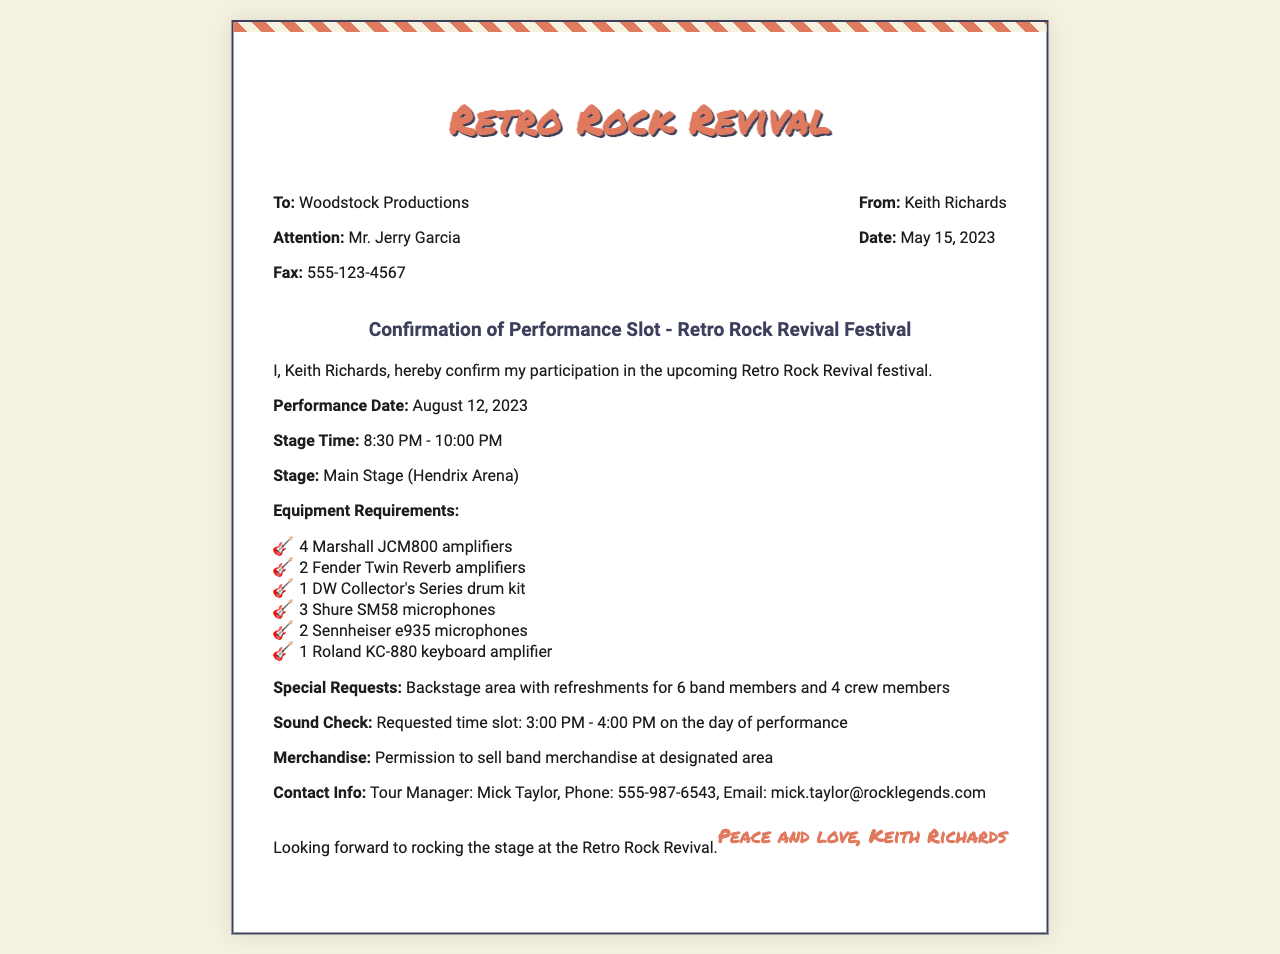What is the performance date? The performance date is explicitly mentioned in the document as August 12, 2023.
Answer: August 12, 2023 What time does the performance start? The start time of the performance is listed as 8:30 PM in the document.
Answer: 8:30 PM How many crew members are specified in special requests? The document states there will be 4 crew members alongside 6 band members in the special requests.
Answer: 4 What is the name of the stage where the performance will take place? The document specifically mentions that the performance will occur at the Main Stage (Hendrix Arena).
Answer: Main Stage (Hendrix Arena) What is the requested time slot for the sound check? The document provides the requested time for the sound check as 3:00 PM to 4:00 PM.
Answer: 3:00 PM - 4:00 PM How many Shure SM58 microphones are required? The number of Shure SM58 microphones requested is explicitly listed in the document as 3.
Answer: 3 Who is the Tour Manager? The document names Mick Taylor as the Tour Manager for the performance.
Answer: Mick Taylor What is the fax number provided in the document? The document lists the fax number as 555-123-4567.
Answer: 555-123-4567 What are the equipment requirements categorized as? The equipment requirements are specifically outlined in a bullet-pointed list in the document.
Answer: Equipment Requirements 